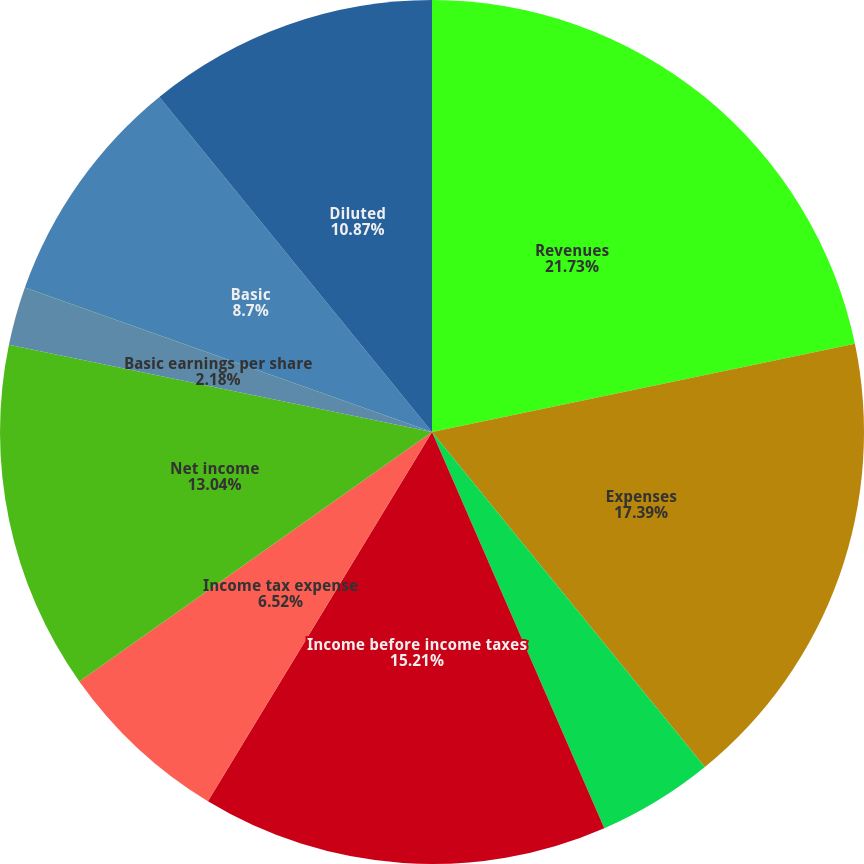Convert chart. <chart><loc_0><loc_0><loc_500><loc_500><pie_chart><fcel>Revenues<fcel>Expenses<fcel>Other income/(expense) net<fcel>Income before income taxes<fcel>Income tax expense<fcel>Net income<fcel>Basic earnings per share<fcel>Diluted earnings per share<fcel>Basic<fcel>Diluted<nl><fcel>21.73%<fcel>17.39%<fcel>4.35%<fcel>15.21%<fcel>6.52%<fcel>13.04%<fcel>2.18%<fcel>0.01%<fcel>8.7%<fcel>10.87%<nl></chart> 